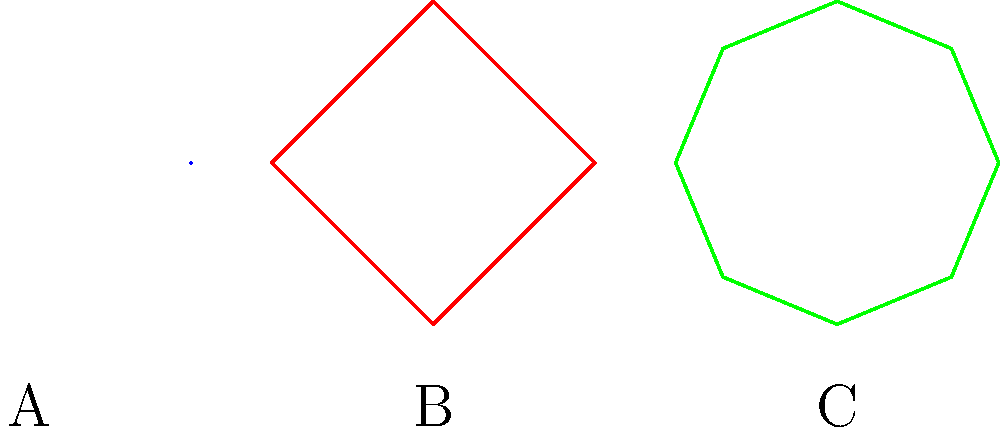As an Olympic athlete, you're familiar with various types of athletic equipment. Based on the shapes shown in the image, which one represents a discus? Let's analyze each shape to determine which one represents a discus:

1. Shape A: This is a straight line, which is characteristic of a javelin. A javelin is a long, spear-like implement used in throwing events.

2. Shape B: This is a square shape, which is closest to the shape of a shot put. Shot puts are spherical but often appear more angular when represented in 2D diagrams.

3. Shape C: This is an octagon, which is the closest representation to a discus among the given shapes. A discus is a flat, circular plate used in throwing events, and an octagon is the most circular shape shown here.

In Olympic competitions, the discus is known for its circular shape, which allows it to be thrown with a spinning motion for maximum distance. The octagonal shape (C) best approximates this circular form among the given options.
Answer: C 